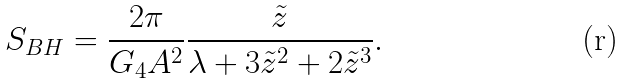<formula> <loc_0><loc_0><loc_500><loc_500>S _ { B H } = \frac { 2 \pi } { G _ { 4 } A ^ { 2 } } \frac { \tilde { z } } { \lambda + 3 \tilde { z } ^ { 2 } + 2 \tilde { z } ^ { 3 } } .</formula> 